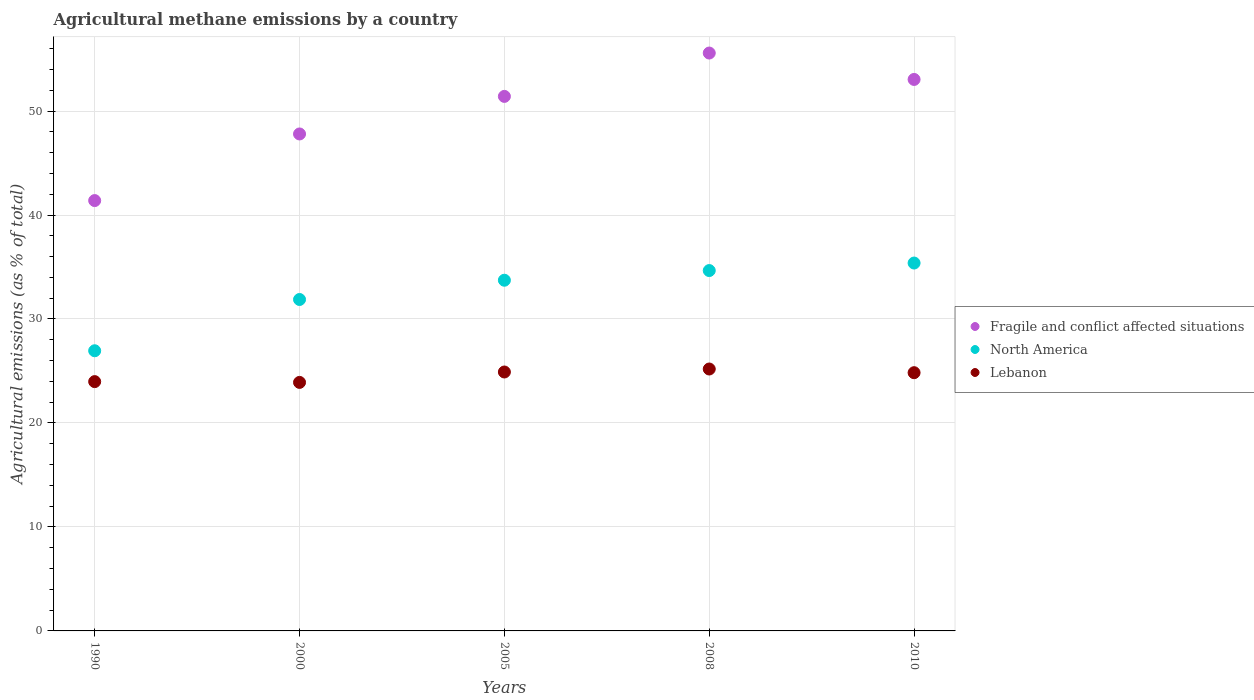How many different coloured dotlines are there?
Make the answer very short. 3. Is the number of dotlines equal to the number of legend labels?
Keep it short and to the point. Yes. What is the amount of agricultural methane emitted in North America in 2005?
Ensure brevity in your answer.  33.73. Across all years, what is the maximum amount of agricultural methane emitted in Lebanon?
Your answer should be compact. 25.19. Across all years, what is the minimum amount of agricultural methane emitted in North America?
Your answer should be compact. 26.95. In which year was the amount of agricultural methane emitted in North America minimum?
Make the answer very short. 1990. What is the total amount of agricultural methane emitted in Lebanon in the graph?
Provide a short and direct response. 122.81. What is the difference between the amount of agricultural methane emitted in Lebanon in 2005 and that in 2008?
Offer a very short reply. -0.29. What is the difference between the amount of agricultural methane emitted in Lebanon in 2000 and the amount of agricultural methane emitted in North America in 2008?
Your response must be concise. -10.76. What is the average amount of agricultural methane emitted in Lebanon per year?
Your answer should be very brief. 24.56. In the year 2008, what is the difference between the amount of agricultural methane emitted in North America and amount of agricultural methane emitted in Fragile and conflict affected situations?
Offer a terse response. -20.92. What is the ratio of the amount of agricultural methane emitted in Fragile and conflict affected situations in 1990 to that in 2000?
Provide a succinct answer. 0.87. Is the amount of agricultural methane emitted in North America in 2005 less than that in 2008?
Make the answer very short. Yes. What is the difference between the highest and the second highest amount of agricultural methane emitted in Fragile and conflict affected situations?
Make the answer very short. 2.54. What is the difference between the highest and the lowest amount of agricultural methane emitted in Lebanon?
Ensure brevity in your answer.  1.29. In how many years, is the amount of agricultural methane emitted in Lebanon greater than the average amount of agricultural methane emitted in Lebanon taken over all years?
Provide a succinct answer. 3. Does the amount of agricultural methane emitted in Lebanon monotonically increase over the years?
Keep it short and to the point. No. Is the amount of agricultural methane emitted in Lebanon strictly less than the amount of agricultural methane emitted in Fragile and conflict affected situations over the years?
Offer a very short reply. Yes. How many years are there in the graph?
Give a very brief answer. 5. What is the difference between two consecutive major ticks on the Y-axis?
Offer a very short reply. 10. Does the graph contain any zero values?
Keep it short and to the point. No. Does the graph contain grids?
Your answer should be compact. Yes. Where does the legend appear in the graph?
Provide a succinct answer. Center right. How many legend labels are there?
Make the answer very short. 3. What is the title of the graph?
Offer a very short reply. Agricultural methane emissions by a country. Does "Sweden" appear as one of the legend labels in the graph?
Your answer should be compact. No. What is the label or title of the Y-axis?
Your answer should be very brief. Agricultural emissions (as % of total). What is the Agricultural emissions (as % of total) in Fragile and conflict affected situations in 1990?
Give a very brief answer. 41.39. What is the Agricultural emissions (as % of total) in North America in 1990?
Ensure brevity in your answer.  26.95. What is the Agricultural emissions (as % of total) of Lebanon in 1990?
Ensure brevity in your answer.  23.98. What is the Agricultural emissions (as % of total) in Fragile and conflict affected situations in 2000?
Provide a succinct answer. 47.8. What is the Agricultural emissions (as % of total) in North America in 2000?
Your answer should be compact. 31.88. What is the Agricultural emissions (as % of total) in Lebanon in 2000?
Keep it short and to the point. 23.9. What is the Agricultural emissions (as % of total) of Fragile and conflict affected situations in 2005?
Keep it short and to the point. 51.41. What is the Agricultural emissions (as % of total) of North America in 2005?
Make the answer very short. 33.73. What is the Agricultural emissions (as % of total) of Lebanon in 2005?
Make the answer very short. 24.9. What is the Agricultural emissions (as % of total) of Fragile and conflict affected situations in 2008?
Your answer should be very brief. 55.58. What is the Agricultural emissions (as % of total) of North America in 2008?
Offer a very short reply. 34.66. What is the Agricultural emissions (as % of total) in Lebanon in 2008?
Your answer should be very brief. 25.19. What is the Agricultural emissions (as % of total) in Fragile and conflict affected situations in 2010?
Your response must be concise. 53.04. What is the Agricultural emissions (as % of total) of North America in 2010?
Provide a succinct answer. 35.38. What is the Agricultural emissions (as % of total) of Lebanon in 2010?
Ensure brevity in your answer.  24.84. Across all years, what is the maximum Agricultural emissions (as % of total) in Fragile and conflict affected situations?
Your response must be concise. 55.58. Across all years, what is the maximum Agricultural emissions (as % of total) in North America?
Provide a short and direct response. 35.38. Across all years, what is the maximum Agricultural emissions (as % of total) in Lebanon?
Provide a short and direct response. 25.19. Across all years, what is the minimum Agricultural emissions (as % of total) in Fragile and conflict affected situations?
Give a very brief answer. 41.39. Across all years, what is the minimum Agricultural emissions (as % of total) of North America?
Offer a very short reply. 26.95. Across all years, what is the minimum Agricultural emissions (as % of total) in Lebanon?
Ensure brevity in your answer.  23.9. What is the total Agricultural emissions (as % of total) in Fragile and conflict affected situations in the graph?
Make the answer very short. 249.21. What is the total Agricultural emissions (as % of total) in North America in the graph?
Provide a succinct answer. 162.59. What is the total Agricultural emissions (as % of total) in Lebanon in the graph?
Provide a succinct answer. 122.81. What is the difference between the Agricultural emissions (as % of total) in Fragile and conflict affected situations in 1990 and that in 2000?
Offer a terse response. -6.41. What is the difference between the Agricultural emissions (as % of total) in North America in 1990 and that in 2000?
Make the answer very short. -4.93. What is the difference between the Agricultural emissions (as % of total) of Lebanon in 1990 and that in 2000?
Provide a short and direct response. 0.07. What is the difference between the Agricultural emissions (as % of total) of Fragile and conflict affected situations in 1990 and that in 2005?
Provide a short and direct response. -10.02. What is the difference between the Agricultural emissions (as % of total) of North America in 1990 and that in 2005?
Provide a succinct answer. -6.78. What is the difference between the Agricultural emissions (as % of total) of Lebanon in 1990 and that in 2005?
Give a very brief answer. -0.93. What is the difference between the Agricultural emissions (as % of total) of Fragile and conflict affected situations in 1990 and that in 2008?
Your answer should be compact. -14.19. What is the difference between the Agricultural emissions (as % of total) in North America in 1990 and that in 2008?
Your answer should be very brief. -7.71. What is the difference between the Agricultural emissions (as % of total) in Lebanon in 1990 and that in 2008?
Offer a terse response. -1.21. What is the difference between the Agricultural emissions (as % of total) in Fragile and conflict affected situations in 1990 and that in 2010?
Your answer should be compact. -11.65. What is the difference between the Agricultural emissions (as % of total) of North America in 1990 and that in 2010?
Your response must be concise. -8.44. What is the difference between the Agricultural emissions (as % of total) in Lebanon in 1990 and that in 2010?
Provide a short and direct response. -0.86. What is the difference between the Agricultural emissions (as % of total) in Fragile and conflict affected situations in 2000 and that in 2005?
Ensure brevity in your answer.  -3.61. What is the difference between the Agricultural emissions (as % of total) of North America in 2000 and that in 2005?
Offer a terse response. -1.85. What is the difference between the Agricultural emissions (as % of total) of Lebanon in 2000 and that in 2005?
Offer a very short reply. -1. What is the difference between the Agricultural emissions (as % of total) of Fragile and conflict affected situations in 2000 and that in 2008?
Give a very brief answer. -7.78. What is the difference between the Agricultural emissions (as % of total) in North America in 2000 and that in 2008?
Offer a terse response. -2.78. What is the difference between the Agricultural emissions (as % of total) of Lebanon in 2000 and that in 2008?
Ensure brevity in your answer.  -1.29. What is the difference between the Agricultural emissions (as % of total) in Fragile and conflict affected situations in 2000 and that in 2010?
Give a very brief answer. -5.24. What is the difference between the Agricultural emissions (as % of total) of North America in 2000 and that in 2010?
Your answer should be very brief. -3.51. What is the difference between the Agricultural emissions (as % of total) in Lebanon in 2000 and that in 2010?
Give a very brief answer. -0.93. What is the difference between the Agricultural emissions (as % of total) of Fragile and conflict affected situations in 2005 and that in 2008?
Make the answer very short. -4.17. What is the difference between the Agricultural emissions (as % of total) of North America in 2005 and that in 2008?
Your answer should be very brief. -0.93. What is the difference between the Agricultural emissions (as % of total) of Lebanon in 2005 and that in 2008?
Your answer should be very brief. -0.29. What is the difference between the Agricultural emissions (as % of total) in Fragile and conflict affected situations in 2005 and that in 2010?
Your response must be concise. -1.63. What is the difference between the Agricultural emissions (as % of total) of North America in 2005 and that in 2010?
Ensure brevity in your answer.  -1.65. What is the difference between the Agricultural emissions (as % of total) in Lebanon in 2005 and that in 2010?
Ensure brevity in your answer.  0.07. What is the difference between the Agricultural emissions (as % of total) in Fragile and conflict affected situations in 2008 and that in 2010?
Your answer should be very brief. 2.54. What is the difference between the Agricultural emissions (as % of total) in North America in 2008 and that in 2010?
Make the answer very short. -0.72. What is the difference between the Agricultural emissions (as % of total) in Lebanon in 2008 and that in 2010?
Provide a short and direct response. 0.35. What is the difference between the Agricultural emissions (as % of total) in Fragile and conflict affected situations in 1990 and the Agricultural emissions (as % of total) in North America in 2000?
Provide a succinct answer. 9.51. What is the difference between the Agricultural emissions (as % of total) in Fragile and conflict affected situations in 1990 and the Agricultural emissions (as % of total) in Lebanon in 2000?
Make the answer very short. 17.49. What is the difference between the Agricultural emissions (as % of total) of North America in 1990 and the Agricultural emissions (as % of total) of Lebanon in 2000?
Offer a very short reply. 3.04. What is the difference between the Agricultural emissions (as % of total) in Fragile and conflict affected situations in 1990 and the Agricultural emissions (as % of total) in North America in 2005?
Keep it short and to the point. 7.66. What is the difference between the Agricultural emissions (as % of total) of Fragile and conflict affected situations in 1990 and the Agricultural emissions (as % of total) of Lebanon in 2005?
Give a very brief answer. 16.49. What is the difference between the Agricultural emissions (as % of total) in North America in 1990 and the Agricultural emissions (as % of total) in Lebanon in 2005?
Offer a terse response. 2.04. What is the difference between the Agricultural emissions (as % of total) of Fragile and conflict affected situations in 1990 and the Agricultural emissions (as % of total) of North America in 2008?
Your response must be concise. 6.73. What is the difference between the Agricultural emissions (as % of total) in Fragile and conflict affected situations in 1990 and the Agricultural emissions (as % of total) in Lebanon in 2008?
Provide a succinct answer. 16.2. What is the difference between the Agricultural emissions (as % of total) of North America in 1990 and the Agricultural emissions (as % of total) of Lebanon in 2008?
Your answer should be compact. 1.76. What is the difference between the Agricultural emissions (as % of total) of Fragile and conflict affected situations in 1990 and the Agricultural emissions (as % of total) of North America in 2010?
Your response must be concise. 6.01. What is the difference between the Agricultural emissions (as % of total) in Fragile and conflict affected situations in 1990 and the Agricultural emissions (as % of total) in Lebanon in 2010?
Ensure brevity in your answer.  16.55. What is the difference between the Agricultural emissions (as % of total) in North America in 1990 and the Agricultural emissions (as % of total) in Lebanon in 2010?
Offer a terse response. 2.11. What is the difference between the Agricultural emissions (as % of total) in Fragile and conflict affected situations in 2000 and the Agricultural emissions (as % of total) in North America in 2005?
Your answer should be very brief. 14.07. What is the difference between the Agricultural emissions (as % of total) of Fragile and conflict affected situations in 2000 and the Agricultural emissions (as % of total) of Lebanon in 2005?
Provide a succinct answer. 22.89. What is the difference between the Agricultural emissions (as % of total) of North America in 2000 and the Agricultural emissions (as % of total) of Lebanon in 2005?
Provide a short and direct response. 6.97. What is the difference between the Agricultural emissions (as % of total) of Fragile and conflict affected situations in 2000 and the Agricultural emissions (as % of total) of North America in 2008?
Your answer should be very brief. 13.14. What is the difference between the Agricultural emissions (as % of total) of Fragile and conflict affected situations in 2000 and the Agricultural emissions (as % of total) of Lebanon in 2008?
Provide a short and direct response. 22.61. What is the difference between the Agricultural emissions (as % of total) of North America in 2000 and the Agricultural emissions (as % of total) of Lebanon in 2008?
Make the answer very short. 6.69. What is the difference between the Agricultural emissions (as % of total) of Fragile and conflict affected situations in 2000 and the Agricultural emissions (as % of total) of North America in 2010?
Make the answer very short. 12.42. What is the difference between the Agricultural emissions (as % of total) in Fragile and conflict affected situations in 2000 and the Agricultural emissions (as % of total) in Lebanon in 2010?
Your answer should be compact. 22.96. What is the difference between the Agricultural emissions (as % of total) in North America in 2000 and the Agricultural emissions (as % of total) in Lebanon in 2010?
Give a very brief answer. 7.04. What is the difference between the Agricultural emissions (as % of total) of Fragile and conflict affected situations in 2005 and the Agricultural emissions (as % of total) of North America in 2008?
Offer a terse response. 16.75. What is the difference between the Agricultural emissions (as % of total) in Fragile and conflict affected situations in 2005 and the Agricultural emissions (as % of total) in Lebanon in 2008?
Provide a succinct answer. 26.22. What is the difference between the Agricultural emissions (as % of total) of North America in 2005 and the Agricultural emissions (as % of total) of Lebanon in 2008?
Offer a terse response. 8.54. What is the difference between the Agricultural emissions (as % of total) in Fragile and conflict affected situations in 2005 and the Agricultural emissions (as % of total) in North America in 2010?
Keep it short and to the point. 16.03. What is the difference between the Agricultural emissions (as % of total) of Fragile and conflict affected situations in 2005 and the Agricultural emissions (as % of total) of Lebanon in 2010?
Keep it short and to the point. 26.57. What is the difference between the Agricultural emissions (as % of total) of North America in 2005 and the Agricultural emissions (as % of total) of Lebanon in 2010?
Provide a succinct answer. 8.89. What is the difference between the Agricultural emissions (as % of total) in Fragile and conflict affected situations in 2008 and the Agricultural emissions (as % of total) in North America in 2010?
Give a very brief answer. 20.2. What is the difference between the Agricultural emissions (as % of total) in Fragile and conflict affected situations in 2008 and the Agricultural emissions (as % of total) in Lebanon in 2010?
Make the answer very short. 30.74. What is the difference between the Agricultural emissions (as % of total) of North America in 2008 and the Agricultural emissions (as % of total) of Lebanon in 2010?
Offer a very short reply. 9.82. What is the average Agricultural emissions (as % of total) of Fragile and conflict affected situations per year?
Ensure brevity in your answer.  49.84. What is the average Agricultural emissions (as % of total) in North America per year?
Provide a short and direct response. 32.52. What is the average Agricultural emissions (as % of total) in Lebanon per year?
Your answer should be compact. 24.56. In the year 1990, what is the difference between the Agricultural emissions (as % of total) of Fragile and conflict affected situations and Agricultural emissions (as % of total) of North America?
Your answer should be very brief. 14.44. In the year 1990, what is the difference between the Agricultural emissions (as % of total) of Fragile and conflict affected situations and Agricultural emissions (as % of total) of Lebanon?
Give a very brief answer. 17.41. In the year 1990, what is the difference between the Agricultural emissions (as % of total) of North America and Agricultural emissions (as % of total) of Lebanon?
Your answer should be compact. 2.97. In the year 2000, what is the difference between the Agricultural emissions (as % of total) in Fragile and conflict affected situations and Agricultural emissions (as % of total) in North America?
Your response must be concise. 15.92. In the year 2000, what is the difference between the Agricultural emissions (as % of total) of Fragile and conflict affected situations and Agricultural emissions (as % of total) of Lebanon?
Give a very brief answer. 23.89. In the year 2000, what is the difference between the Agricultural emissions (as % of total) of North America and Agricultural emissions (as % of total) of Lebanon?
Ensure brevity in your answer.  7.97. In the year 2005, what is the difference between the Agricultural emissions (as % of total) in Fragile and conflict affected situations and Agricultural emissions (as % of total) in North America?
Your answer should be very brief. 17.68. In the year 2005, what is the difference between the Agricultural emissions (as % of total) in Fragile and conflict affected situations and Agricultural emissions (as % of total) in Lebanon?
Your answer should be compact. 26.51. In the year 2005, what is the difference between the Agricultural emissions (as % of total) of North America and Agricultural emissions (as % of total) of Lebanon?
Your response must be concise. 8.83. In the year 2008, what is the difference between the Agricultural emissions (as % of total) of Fragile and conflict affected situations and Agricultural emissions (as % of total) of North America?
Offer a very short reply. 20.92. In the year 2008, what is the difference between the Agricultural emissions (as % of total) of Fragile and conflict affected situations and Agricultural emissions (as % of total) of Lebanon?
Give a very brief answer. 30.39. In the year 2008, what is the difference between the Agricultural emissions (as % of total) of North America and Agricultural emissions (as % of total) of Lebanon?
Your answer should be compact. 9.47. In the year 2010, what is the difference between the Agricultural emissions (as % of total) of Fragile and conflict affected situations and Agricultural emissions (as % of total) of North America?
Give a very brief answer. 17.66. In the year 2010, what is the difference between the Agricultural emissions (as % of total) in Fragile and conflict affected situations and Agricultural emissions (as % of total) in Lebanon?
Provide a short and direct response. 28.2. In the year 2010, what is the difference between the Agricultural emissions (as % of total) in North America and Agricultural emissions (as % of total) in Lebanon?
Make the answer very short. 10.55. What is the ratio of the Agricultural emissions (as % of total) of Fragile and conflict affected situations in 1990 to that in 2000?
Give a very brief answer. 0.87. What is the ratio of the Agricultural emissions (as % of total) of North America in 1990 to that in 2000?
Your response must be concise. 0.85. What is the ratio of the Agricultural emissions (as % of total) in Fragile and conflict affected situations in 1990 to that in 2005?
Give a very brief answer. 0.81. What is the ratio of the Agricultural emissions (as % of total) of North America in 1990 to that in 2005?
Offer a terse response. 0.8. What is the ratio of the Agricultural emissions (as % of total) in Lebanon in 1990 to that in 2005?
Offer a very short reply. 0.96. What is the ratio of the Agricultural emissions (as % of total) in Fragile and conflict affected situations in 1990 to that in 2008?
Provide a short and direct response. 0.74. What is the ratio of the Agricultural emissions (as % of total) of North America in 1990 to that in 2008?
Offer a very short reply. 0.78. What is the ratio of the Agricultural emissions (as % of total) in Lebanon in 1990 to that in 2008?
Keep it short and to the point. 0.95. What is the ratio of the Agricultural emissions (as % of total) of Fragile and conflict affected situations in 1990 to that in 2010?
Provide a short and direct response. 0.78. What is the ratio of the Agricultural emissions (as % of total) of North America in 1990 to that in 2010?
Your answer should be compact. 0.76. What is the ratio of the Agricultural emissions (as % of total) in Lebanon in 1990 to that in 2010?
Your response must be concise. 0.97. What is the ratio of the Agricultural emissions (as % of total) of Fragile and conflict affected situations in 2000 to that in 2005?
Your answer should be very brief. 0.93. What is the ratio of the Agricultural emissions (as % of total) of North America in 2000 to that in 2005?
Your answer should be compact. 0.95. What is the ratio of the Agricultural emissions (as % of total) in Lebanon in 2000 to that in 2005?
Offer a terse response. 0.96. What is the ratio of the Agricultural emissions (as % of total) of Fragile and conflict affected situations in 2000 to that in 2008?
Offer a very short reply. 0.86. What is the ratio of the Agricultural emissions (as % of total) of North America in 2000 to that in 2008?
Offer a terse response. 0.92. What is the ratio of the Agricultural emissions (as % of total) of Lebanon in 2000 to that in 2008?
Make the answer very short. 0.95. What is the ratio of the Agricultural emissions (as % of total) of Fragile and conflict affected situations in 2000 to that in 2010?
Provide a short and direct response. 0.9. What is the ratio of the Agricultural emissions (as % of total) in North America in 2000 to that in 2010?
Your answer should be compact. 0.9. What is the ratio of the Agricultural emissions (as % of total) of Lebanon in 2000 to that in 2010?
Make the answer very short. 0.96. What is the ratio of the Agricultural emissions (as % of total) of Fragile and conflict affected situations in 2005 to that in 2008?
Ensure brevity in your answer.  0.93. What is the ratio of the Agricultural emissions (as % of total) of North America in 2005 to that in 2008?
Keep it short and to the point. 0.97. What is the ratio of the Agricultural emissions (as % of total) of Lebanon in 2005 to that in 2008?
Your answer should be very brief. 0.99. What is the ratio of the Agricultural emissions (as % of total) in Fragile and conflict affected situations in 2005 to that in 2010?
Your answer should be very brief. 0.97. What is the ratio of the Agricultural emissions (as % of total) in North America in 2005 to that in 2010?
Your answer should be very brief. 0.95. What is the ratio of the Agricultural emissions (as % of total) of Lebanon in 2005 to that in 2010?
Offer a very short reply. 1. What is the ratio of the Agricultural emissions (as % of total) in Fragile and conflict affected situations in 2008 to that in 2010?
Give a very brief answer. 1.05. What is the ratio of the Agricultural emissions (as % of total) in North America in 2008 to that in 2010?
Offer a very short reply. 0.98. What is the ratio of the Agricultural emissions (as % of total) of Lebanon in 2008 to that in 2010?
Your response must be concise. 1.01. What is the difference between the highest and the second highest Agricultural emissions (as % of total) of Fragile and conflict affected situations?
Your answer should be compact. 2.54. What is the difference between the highest and the second highest Agricultural emissions (as % of total) in North America?
Provide a succinct answer. 0.72. What is the difference between the highest and the second highest Agricultural emissions (as % of total) of Lebanon?
Your answer should be compact. 0.29. What is the difference between the highest and the lowest Agricultural emissions (as % of total) in Fragile and conflict affected situations?
Make the answer very short. 14.19. What is the difference between the highest and the lowest Agricultural emissions (as % of total) in North America?
Offer a very short reply. 8.44. What is the difference between the highest and the lowest Agricultural emissions (as % of total) of Lebanon?
Your answer should be compact. 1.29. 